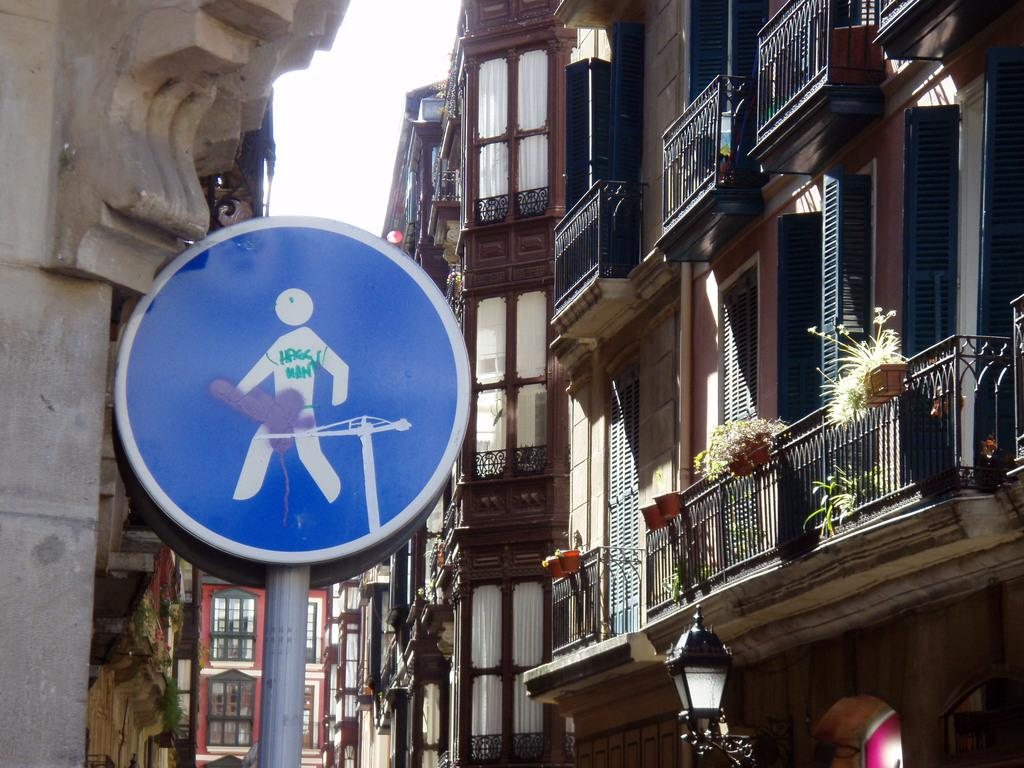What type of structures can be seen in the image? There are buildings in the image. What other objects are present in the image besides buildings? There are sign boards, grills, houseplants, and street lights in the image. What can be seen in the sky in the image? The sky is visible in the image. How many hearts can be seen in the image? There are no hearts visible in the image. What type of thing is present in the image that is not mentioned in the facts? There is no information about any additional objects or elements in the image that are not mentioned in the facts. 